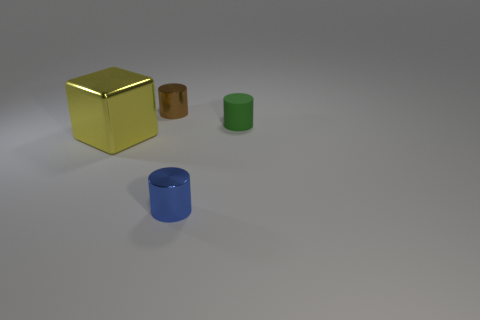There is a cylinder that is right of the small metallic thing that is in front of the shiny cylinder that is on the left side of the blue shiny cylinder; what size is it?
Your answer should be compact. Small. Is the color of the shiny cylinder that is in front of the green rubber cylinder the same as the small metal thing that is on the left side of the blue metal object?
Provide a succinct answer. No. How many yellow things are either large cubes or tiny cylinders?
Ensure brevity in your answer.  1. What number of matte cylinders are the same size as the brown thing?
Your response must be concise. 1. Are the small cylinder that is left of the blue object and the small green thing made of the same material?
Offer a terse response. No. Is there a brown shiny object that is on the right side of the tiny blue metal thing in front of the tiny brown metal cylinder?
Your response must be concise. No. There is a small brown thing that is the same shape as the tiny green rubber thing; what is it made of?
Keep it short and to the point. Metal. Is the number of big yellow metal objects that are on the left side of the big yellow metal block greater than the number of metallic cubes that are right of the tiny brown shiny cylinder?
Offer a terse response. No. There is a big thing that is made of the same material as the small brown object; what is its shape?
Your answer should be very brief. Cube. Are there more things in front of the yellow metallic thing than tiny blue cylinders?
Ensure brevity in your answer.  No. 